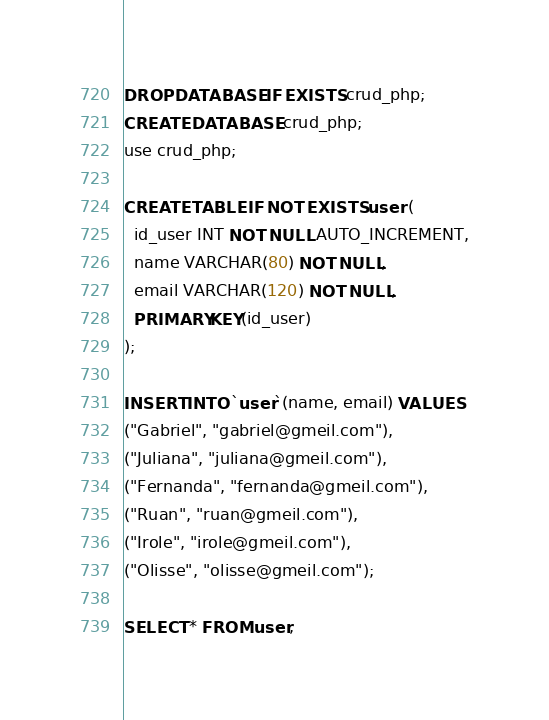<code> <loc_0><loc_0><loc_500><loc_500><_SQL_>DROP DATABASE IF EXISTS crud_php;
CREATE DATABASE crud_php;
use crud_php;

CREATE TABLE IF NOT EXISTS user (
  id_user INT NOT NULL AUTO_INCREMENT,
  name VARCHAR(80) NOT NULL,
  email VARCHAR(120) NOT NULL,
  PRIMARY KEY(id_user)
);

INSERT INTO `user`(name, email) VALUES
("Gabriel", "gabriel@gmeil.com"),
("Juliana", "juliana@gmeil.com"),
("Fernanda", "fernanda@gmeil.com"),
("Ruan", "ruan@gmeil.com"),
("Irole", "irole@gmeil.com"),
("Olisse", "olisse@gmeil.com");

SELECT * FROM user;</code> 